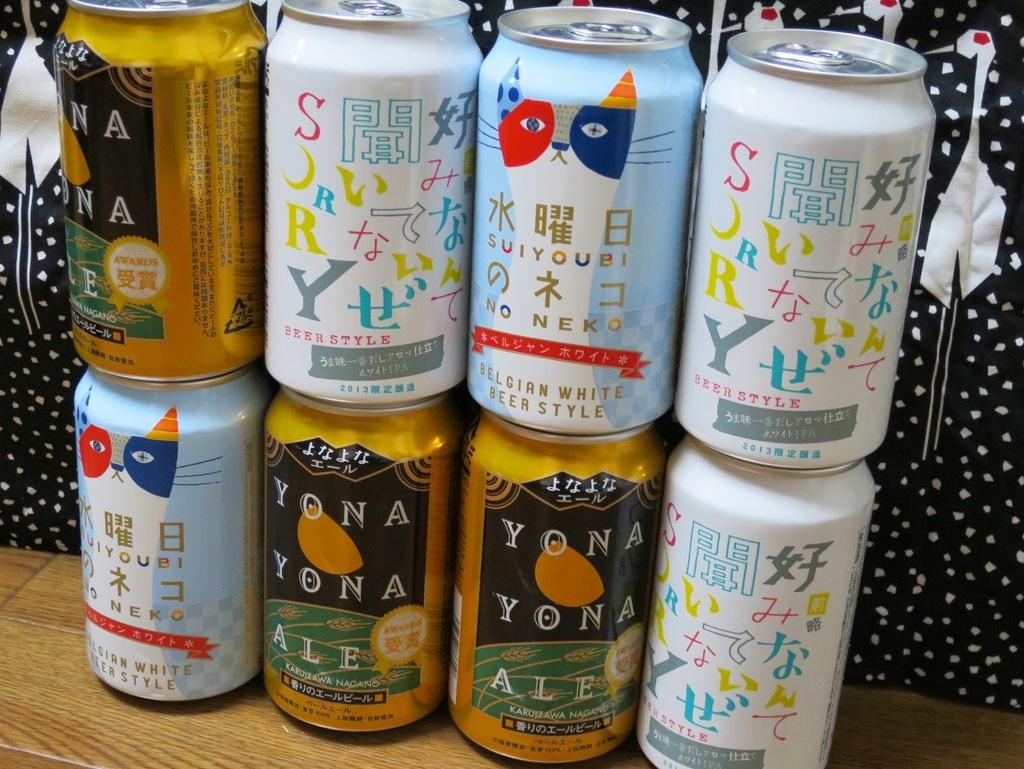What brand is the gold can?
Keep it short and to the point. Yona yona ale. What brand is the can with the cat on it?
Provide a short and direct response. Suiyoubi no neko. 